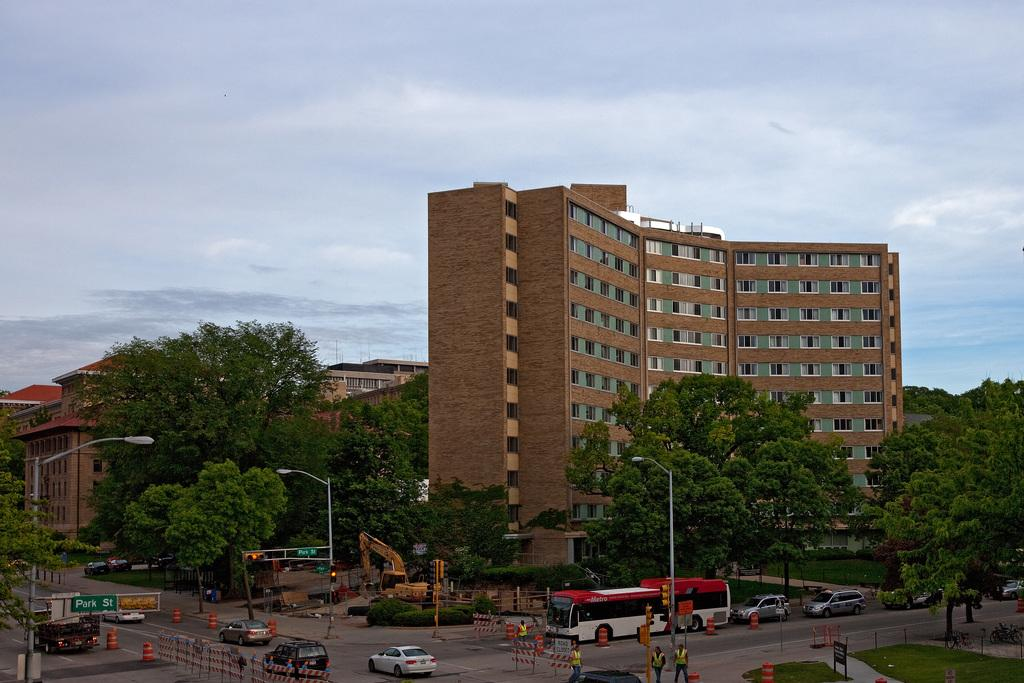What type of structures can be seen in the image? There are buildings in the image. What type of vegetation is present in the image? There are trees and grass in the image. What type of lighting is present in the image? There are street lamps in the image. What type of vehicle is present in the image? There is a bus in the image. What type of construction equipment is present in the image? There is a crane in the image. What type of transportation is present in the image? There are cars in the image. What type of barrier is present in the image? There is a fence in the image. What type of signage is present in the image? There is a banner in the image. What part of the natural environment is visible in the image? The sky is visible at the top of the image. How many family members can be seen in the image? There is no family present in the image. What type of house is depicted in the image? There is no house depicted in the image. What shape is the square in the image? There is no square present in the image. 